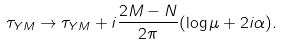Convert formula to latex. <formula><loc_0><loc_0><loc_500><loc_500>\tau _ { Y M } \rightarrow \tau _ { Y M } + i \frac { 2 M - N } { 2 \pi } ( \log \mu + 2 i \alpha ) .</formula> 